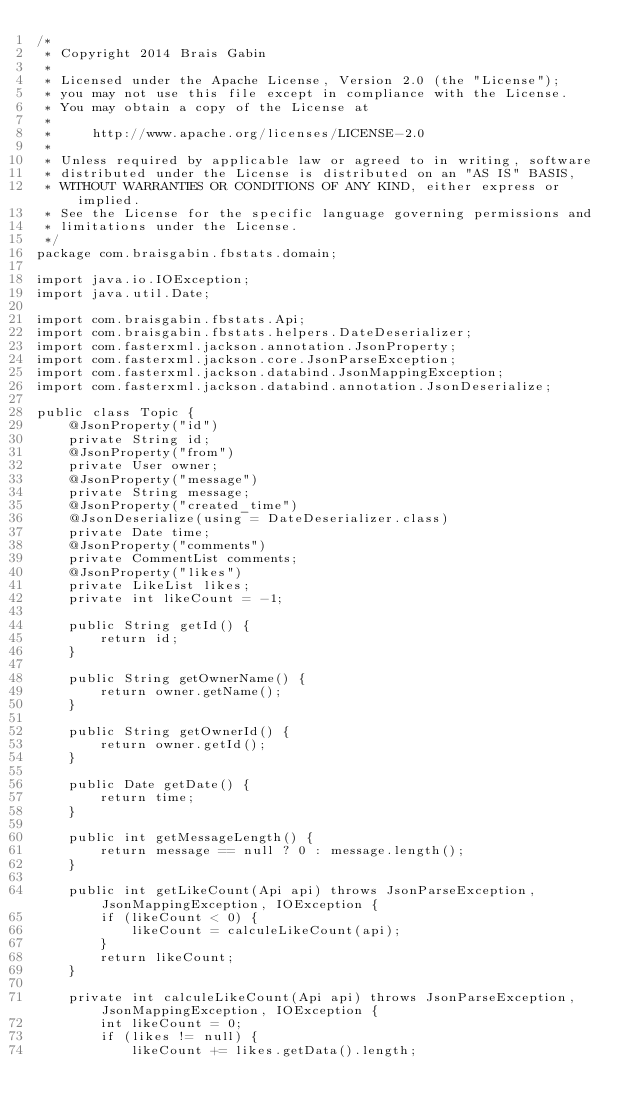<code> <loc_0><loc_0><loc_500><loc_500><_Java_>/*
 * Copyright 2014 Brais Gabin
 * 
 * Licensed under the Apache License, Version 2.0 (the "License");
 * you may not use this file except in compliance with the License.
 * You may obtain a copy of the License at
 * 
 *     http://www.apache.org/licenses/LICENSE-2.0
 *     
 * Unless required by applicable law or agreed to in writing, software
 * distributed under the License is distributed on an "AS IS" BASIS,
 * WITHOUT WARRANTIES OR CONDITIONS OF ANY KIND, either express or implied.
 * See the License for the specific language governing permissions and
 * limitations under the License.
 */
package com.braisgabin.fbstats.domain;

import java.io.IOException;
import java.util.Date;

import com.braisgabin.fbstats.Api;
import com.braisgabin.fbstats.helpers.DateDeserializer;
import com.fasterxml.jackson.annotation.JsonProperty;
import com.fasterxml.jackson.core.JsonParseException;
import com.fasterxml.jackson.databind.JsonMappingException;
import com.fasterxml.jackson.databind.annotation.JsonDeserialize;

public class Topic {
	@JsonProperty("id")
	private String id;
	@JsonProperty("from")
	private User owner;
	@JsonProperty("message")
	private String message;
	@JsonProperty("created_time")
	@JsonDeserialize(using = DateDeserializer.class)
	private Date time;
	@JsonProperty("comments")
	private CommentList comments;
	@JsonProperty("likes")
	private LikeList likes;
	private int likeCount = -1;

	public String getId() {
		return id;
	}

	public String getOwnerName() {
		return owner.getName();
	}

	public String getOwnerId() {
		return owner.getId();
	}

	public Date getDate() {
		return time;
	}

	public int getMessageLength() {
		return message == null ? 0 : message.length();
	}

	public int getLikeCount(Api api) throws JsonParseException, JsonMappingException, IOException {
		if (likeCount < 0) {
			likeCount = calculeLikeCount(api);
		}
		return likeCount;
	}

	private int calculeLikeCount(Api api) throws JsonParseException, JsonMappingException, IOException {
		int likeCount = 0;
		if (likes != null) {
			likeCount += likes.getData().length;</code> 